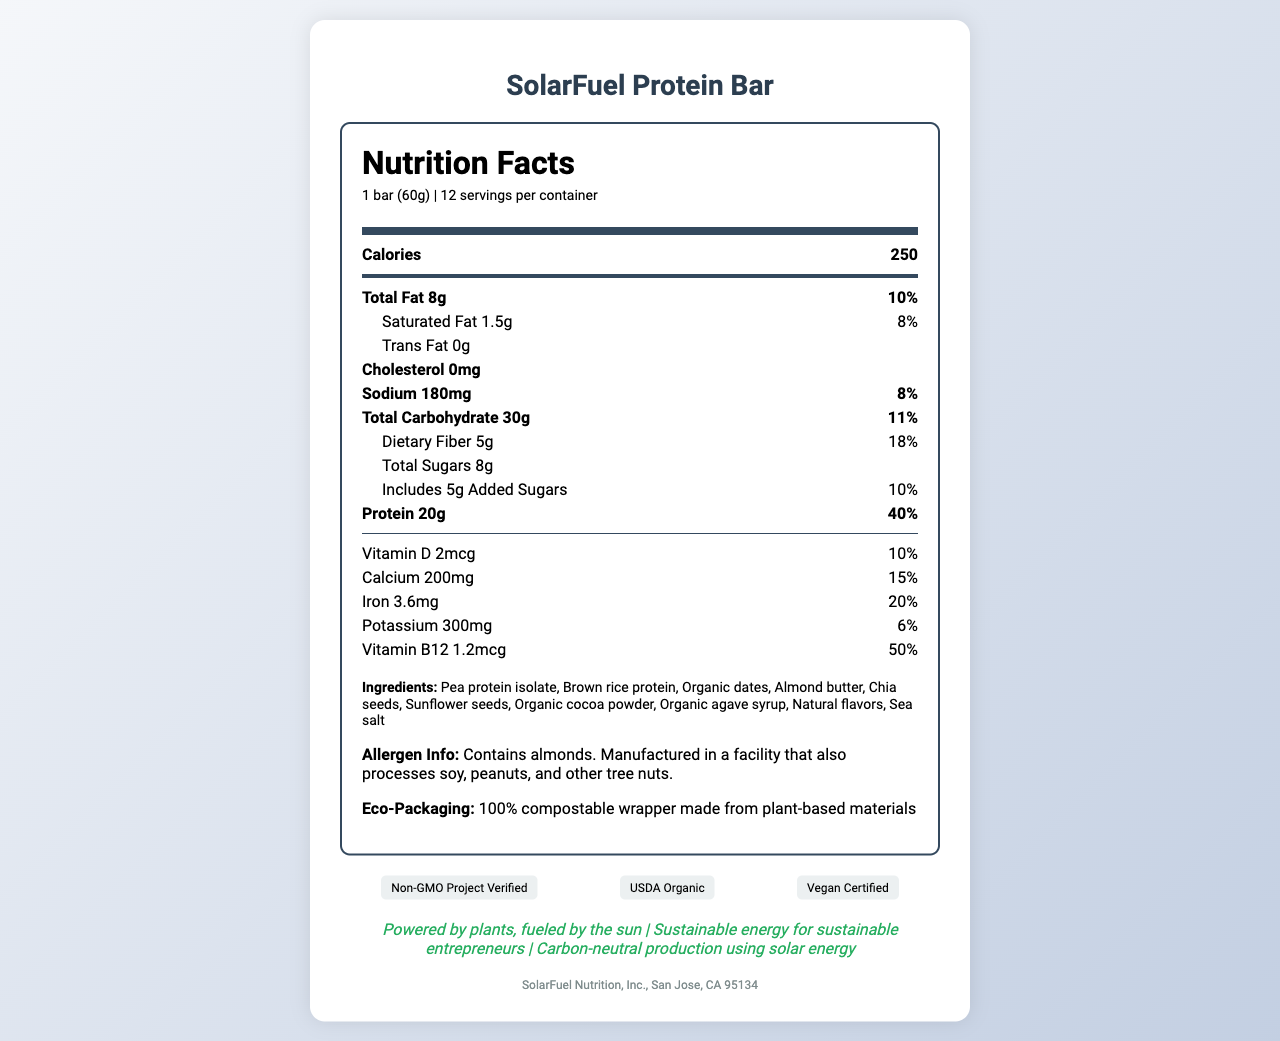what is the serving size of SolarFuel Protein Bar? The serving size is listed as "1 bar (60g)" at the beginning of the Nutrition Facts section.
Answer: 1 bar (60g) how many calories are in one serving? The calorie count is listed as 250 in the bold nutrition item section.
Answer: 250 what is the total amount of protein per bar? The amount of protein is specified as "Protein 20g" in the bold nutrition item section.
Answer: 20g how much dietary fiber does the SolarFuel Protein Bar contain? In the sub-item under total carbohydrates, dietary fiber is listed as 5g.
Answer: 5g how much total fat is in one bar? The total fat is specified as "Total Fat 8g" in the bold nutrition item section.
Answer: 8g how many added sugars are included in the SolarFuel Protein Bar? The amount of added sugars is "5g" under the sub-item section for total sugars.
Answer: 5g what vitamins and minerals are listed on the nutrition label? The vitamins and minerals listed are Vitamin D, Calcium, Iron, Potassium, and Vitamin B12 in the nutrition item section.
Answer: Vitamin D, Calcium, Iron, Potassium, and Vitamin B12 what certifications does the SolarFuel Protein Bar have? A. USDA Organic B. Gluten-Free C. Vegan Certified D. Non-GMO Project Verified The certifications listed are Non-GMO Project Verified, USDA Organic, and Vegan Certified.
Answer: A, C, D how many servings are there per container? A. 8 B. 10 C. 12 D. 14 The document states that there are 12 servings per container.
Answer: C is there any cholesterol in the SolarFuel Protein Bar? The cholesterol amount is listed as "0mg".
Answer: No does the SolarFuel Protein Bar contain any tree nuts? The allergen information states it contains almonds.
Answer: Yes what is the main idea of the document? The document outlines the nutritional facts, ingredients, allergen info, eco-packaging details, certifications, marketing claims, and company info for the SolarFuel Protein Bar.
Answer: The document provides nutritional information and marketing claims for the SolarFuel Protein Bar, highlighting its plant-based ingredients, eco-conscious packaging, and sustainable production. what is the potassium daily value percentage in the SolarFuel Protein Bar? The potassium daily value percentage is listed as "6%" in the nutrition item section.
Answer: 6% how much calcium is in one serving of the SolarFuel Protein Bar? The document lists the amount of calcium as "200mg".
Answer: 200mg how is the wrapper of the SolarFuel Protein Bar described? The eco-packaging section states the wrapper is made from 100% compostable plant-based materials.
Answer: 100% compostable wrapper made from plant-based materials what does the marketing claim "Powered by plants, fueled by the sun" mean? The document contains the claim, but it does not explain what it specifically means.
Answer: Not enough information 